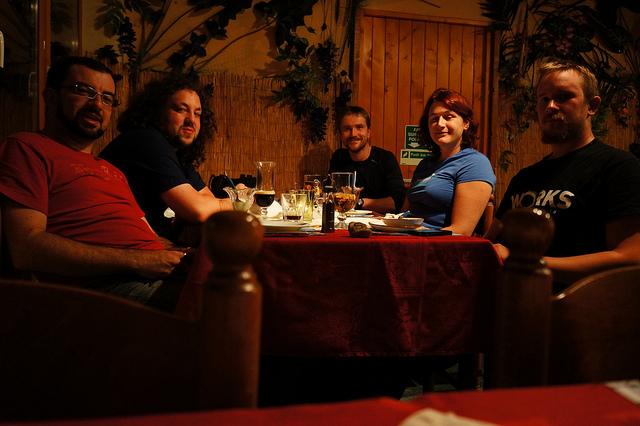How many men are photographed?
Give a very brief answer. 4. What word is on the man's shirt who is sitting the furthest to the right in the picture?
Give a very brief answer. Works. Is there only one woman there?
Give a very brief answer. Yes. 